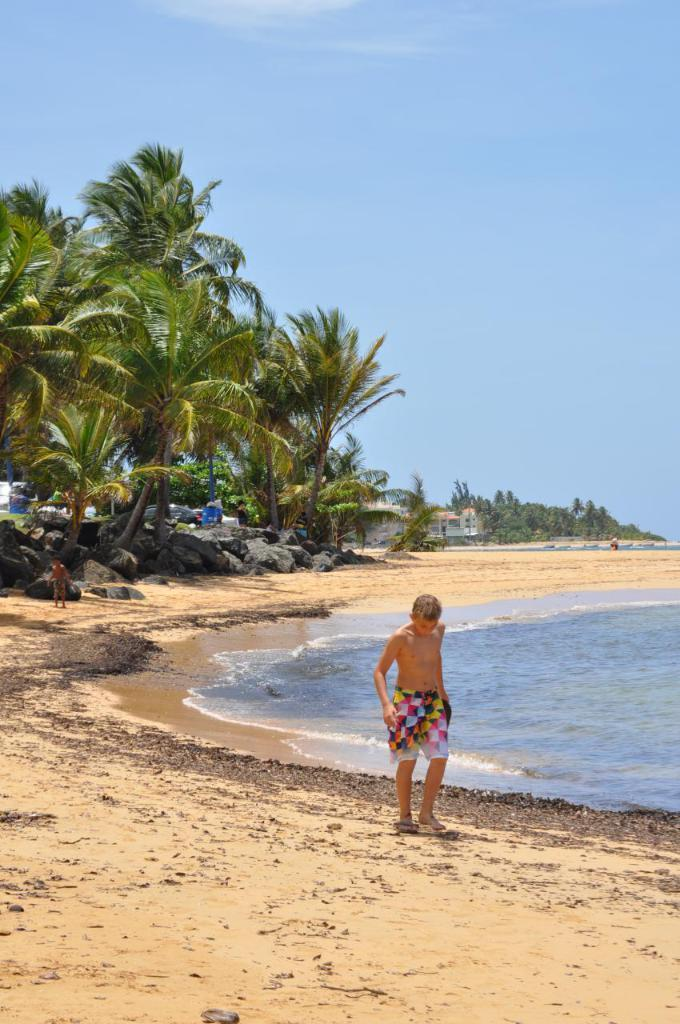Who or what is in the center of the image? There is a person in the center of the image. What natural feature can be seen on the right side of the image? There is a sea on the right side of the image. What type of vegetation is visible in the background of the image? There are trees in the background of the image. What man-made structures can be seen in the background of the image? There are buildings in the background of the image. What part of the sky is visible in the image? The sky is visible in the background of the image. What is visible at the bottom of the image? The sea shore is visible at the bottom of the image. How many cakes are being served by the person in the image? There is no mention of cakes or any food items in the image; the person is not serving anything. 